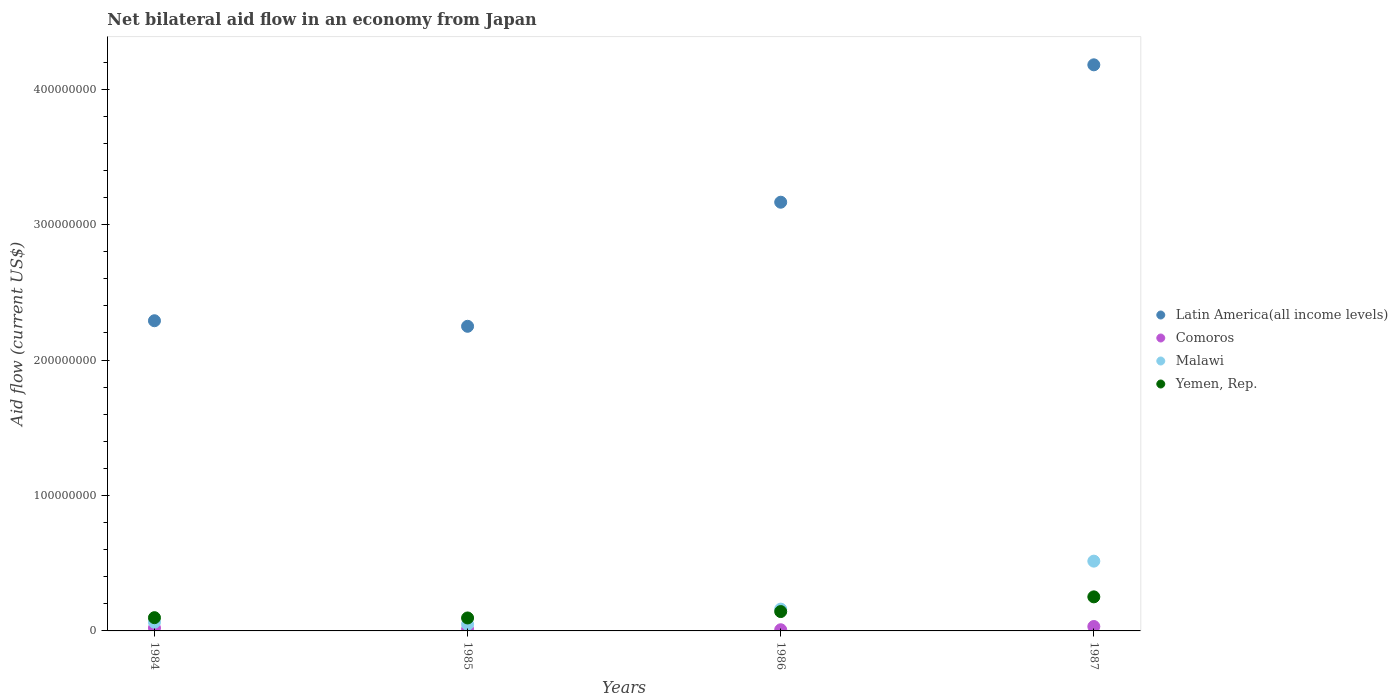Is the number of dotlines equal to the number of legend labels?
Make the answer very short. Yes. What is the net bilateral aid flow in Yemen, Rep. in 1984?
Give a very brief answer. 9.78e+06. Across all years, what is the maximum net bilateral aid flow in Yemen, Rep.?
Keep it short and to the point. 2.52e+07. Across all years, what is the minimum net bilateral aid flow in Comoros?
Offer a terse response. 8.60e+05. In which year was the net bilateral aid flow in Latin America(all income levels) maximum?
Your answer should be compact. 1987. What is the total net bilateral aid flow in Yemen, Rep. in the graph?
Provide a succinct answer. 5.88e+07. What is the difference between the net bilateral aid flow in Latin America(all income levels) in 1985 and that in 1987?
Keep it short and to the point. -1.93e+08. What is the difference between the net bilateral aid flow in Yemen, Rep. in 1985 and the net bilateral aid flow in Latin America(all income levels) in 1987?
Provide a short and direct response. -4.08e+08. What is the average net bilateral aid flow in Yemen, Rep. per year?
Keep it short and to the point. 1.47e+07. In the year 1984, what is the difference between the net bilateral aid flow in Latin America(all income levels) and net bilateral aid flow in Yemen, Rep.?
Provide a succinct answer. 2.19e+08. In how many years, is the net bilateral aid flow in Yemen, Rep. greater than 320000000 US$?
Your answer should be very brief. 0. What is the ratio of the net bilateral aid flow in Latin America(all income levels) in 1984 to that in 1986?
Provide a succinct answer. 0.72. Is the difference between the net bilateral aid flow in Latin America(all income levels) in 1985 and 1987 greater than the difference between the net bilateral aid flow in Yemen, Rep. in 1985 and 1987?
Your answer should be very brief. No. What is the difference between the highest and the second highest net bilateral aid flow in Yemen, Rep.?
Make the answer very short. 1.09e+07. What is the difference between the highest and the lowest net bilateral aid flow in Malawi?
Keep it short and to the point. 4.66e+07. Is it the case that in every year, the sum of the net bilateral aid flow in Yemen, Rep. and net bilateral aid flow in Comoros  is greater than the sum of net bilateral aid flow in Latin America(all income levels) and net bilateral aid flow in Malawi?
Offer a very short reply. No. Does the net bilateral aid flow in Malawi monotonically increase over the years?
Keep it short and to the point. No. Is the net bilateral aid flow in Yemen, Rep. strictly greater than the net bilateral aid flow in Latin America(all income levels) over the years?
Give a very brief answer. No. Is the net bilateral aid flow in Malawi strictly less than the net bilateral aid flow in Yemen, Rep. over the years?
Provide a succinct answer. No. How many dotlines are there?
Offer a very short reply. 4. Where does the legend appear in the graph?
Ensure brevity in your answer.  Center right. What is the title of the graph?
Provide a short and direct response. Net bilateral aid flow in an economy from Japan. Does "Palau" appear as one of the legend labels in the graph?
Your response must be concise. No. What is the Aid flow (current US$) of Latin America(all income levels) in 1984?
Keep it short and to the point. 2.29e+08. What is the Aid flow (current US$) of Comoros in 1984?
Your answer should be very brief. 2.18e+06. What is the Aid flow (current US$) of Malawi in 1984?
Offer a terse response. 6.40e+06. What is the Aid flow (current US$) in Yemen, Rep. in 1984?
Make the answer very short. 9.78e+06. What is the Aid flow (current US$) in Latin America(all income levels) in 1985?
Your answer should be compact. 2.25e+08. What is the Aid flow (current US$) of Comoros in 1985?
Make the answer very short. 1.21e+06. What is the Aid flow (current US$) of Malawi in 1985?
Offer a terse response. 4.88e+06. What is the Aid flow (current US$) in Yemen, Rep. in 1985?
Your answer should be very brief. 9.57e+06. What is the Aid flow (current US$) in Latin America(all income levels) in 1986?
Keep it short and to the point. 3.17e+08. What is the Aid flow (current US$) in Comoros in 1986?
Offer a very short reply. 8.60e+05. What is the Aid flow (current US$) of Malawi in 1986?
Make the answer very short. 1.61e+07. What is the Aid flow (current US$) in Yemen, Rep. in 1986?
Your answer should be compact. 1.43e+07. What is the Aid flow (current US$) of Latin America(all income levels) in 1987?
Your answer should be very brief. 4.18e+08. What is the Aid flow (current US$) in Comoros in 1987?
Offer a very short reply. 3.25e+06. What is the Aid flow (current US$) in Malawi in 1987?
Give a very brief answer. 5.15e+07. What is the Aid flow (current US$) of Yemen, Rep. in 1987?
Offer a very short reply. 2.52e+07. Across all years, what is the maximum Aid flow (current US$) of Latin America(all income levels)?
Keep it short and to the point. 4.18e+08. Across all years, what is the maximum Aid flow (current US$) in Comoros?
Provide a succinct answer. 3.25e+06. Across all years, what is the maximum Aid flow (current US$) of Malawi?
Provide a short and direct response. 5.15e+07. Across all years, what is the maximum Aid flow (current US$) in Yemen, Rep.?
Provide a succinct answer. 2.52e+07. Across all years, what is the minimum Aid flow (current US$) of Latin America(all income levels)?
Your answer should be compact. 2.25e+08. Across all years, what is the minimum Aid flow (current US$) of Comoros?
Your response must be concise. 8.60e+05. Across all years, what is the minimum Aid flow (current US$) in Malawi?
Provide a short and direct response. 4.88e+06. Across all years, what is the minimum Aid flow (current US$) in Yemen, Rep.?
Offer a terse response. 9.57e+06. What is the total Aid flow (current US$) of Latin America(all income levels) in the graph?
Offer a very short reply. 1.19e+09. What is the total Aid flow (current US$) in Comoros in the graph?
Offer a very short reply. 7.50e+06. What is the total Aid flow (current US$) of Malawi in the graph?
Provide a succinct answer. 7.89e+07. What is the total Aid flow (current US$) in Yemen, Rep. in the graph?
Provide a short and direct response. 5.88e+07. What is the difference between the Aid flow (current US$) in Latin America(all income levels) in 1984 and that in 1985?
Your answer should be very brief. 4.10e+06. What is the difference between the Aid flow (current US$) in Comoros in 1984 and that in 1985?
Offer a terse response. 9.70e+05. What is the difference between the Aid flow (current US$) of Malawi in 1984 and that in 1985?
Your response must be concise. 1.52e+06. What is the difference between the Aid flow (current US$) in Latin America(all income levels) in 1984 and that in 1986?
Offer a very short reply. -8.75e+07. What is the difference between the Aid flow (current US$) of Comoros in 1984 and that in 1986?
Your answer should be very brief. 1.32e+06. What is the difference between the Aid flow (current US$) of Malawi in 1984 and that in 1986?
Your answer should be very brief. -9.70e+06. What is the difference between the Aid flow (current US$) in Yemen, Rep. in 1984 and that in 1986?
Your response must be concise. -4.51e+06. What is the difference between the Aid flow (current US$) of Latin America(all income levels) in 1984 and that in 1987?
Ensure brevity in your answer.  -1.89e+08. What is the difference between the Aid flow (current US$) of Comoros in 1984 and that in 1987?
Keep it short and to the point. -1.07e+06. What is the difference between the Aid flow (current US$) of Malawi in 1984 and that in 1987?
Offer a terse response. -4.51e+07. What is the difference between the Aid flow (current US$) in Yemen, Rep. in 1984 and that in 1987?
Your response must be concise. -1.54e+07. What is the difference between the Aid flow (current US$) in Latin America(all income levels) in 1985 and that in 1986?
Make the answer very short. -9.16e+07. What is the difference between the Aid flow (current US$) in Comoros in 1985 and that in 1986?
Keep it short and to the point. 3.50e+05. What is the difference between the Aid flow (current US$) of Malawi in 1985 and that in 1986?
Offer a terse response. -1.12e+07. What is the difference between the Aid flow (current US$) in Yemen, Rep. in 1985 and that in 1986?
Keep it short and to the point. -4.72e+06. What is the difference between the Aid flow (current US$) in Latin America(all income levels) in 1985 and that in 1987?
Offer a terse response. -1.93e+08. What is the difference between the Aid flow (current US$) of Comoros in 1985 and that in 1987?
Offer a terse response. -2.04e+06. What is the difference between the Aid flow (current US$) of Malawi in 1985 and that in 1987?
Make the answer very short. -4.66e+07. What is the difference between the Aid flow (current US$) in Yemen, Rep. in 1985 and that in 1987?
Provide a short and direct response. -1.56e+07. What is the difference between the Aid flow (current US$) in Latin America(all income levels) in 1986 and that in 1987?
Keep it short and to the point. -1.01e+08. What is the difference between the Aid flow (current US$) of Comoros in 1986 and that in 1987?
Offer a terse response. -2.39e+06. What is the difference between the Aid flow (current US$) of Malawi in 1986 and that in 1987?
Your answer should be very brief. -3.54e+07. What is the difference between the Aid flow (current US$) in Yemen, Rep. in 1986 and that in 1987?
Your response must be concise. -1.09e+07. What is the difference between the Aid flow (current US$) of Latin America(all income levels) in 1984 and the Aid flow (current US$) of Comoros in 1985?
Your answer should be very brief. 2.28e+08. What is the difference between the Aid flow (current US$) in Latin America(all income levels) in 1984 and the Aid flow (current US$) in Malawi in 1985?
Ensure brevity in your answer.  2.24e+08. What is the difference between the Aid flow (current US$) of Latin America(all income levels) in 1984 and the Aid flow (current US$) of Yemen, Rep. in 1985?
Provide a succinct answer. 2.19e+08. What is the difference between the Aid flow (current US$) in Comoros in 1984 and the Aid flow (current US$) in Malawi in 1985?
Keep it short and to the point. -2.70e+06. What is the difference between the Aid flow (current US$) of Comoros in 1984 and the Aid flow (current US$) of Yemen, Rep. in 1985?
Ensure brevity in your answer.  -7.39e+06. What is the difference between the Aid flow (current US$) in Malawi in 1984 and the Aid flow (current US$) in Yemen, Rep. in 1985?
Give a very brief answer. -3.17e+06. What is the difference between the Aid flow (current US$) in Latin America(all income levels) in 1984 and the Aid flow (current US$) in Comoros in 1986?
Make the answer very short. 2.28e+08. What is the difference between the Aid flow (current US$) of Latin America(all income levels) in 1984 and the Aid flow (current US$) of Malawi in 1986?
Make the answer very short. 2.13e+08. What is the difference between the Aid flow (current US$) in Latin America(all income levels) in 1984 and the Aid flow (current US$) in Yemen, Rep. in 1986?
Give a very brief answer. 2.15e+08. What is the difference between the Aid flow (current US$) of Comoros in 1984 and the Aid flow (current US$) of Malawi in 1986?
Ensure brevity in your answer.  -1.39e+07. What is the difference between the Aid flow (current US$) in Comoros in 1984 and the Aid flow (current US$) in Yemen, Rep. in 1986?
Your answer should be compact. -1.21e+07. What is the difference between the Aid flow (current US$) of Malawi in 1984 and the Aid flow (current US$) of Yemen, Rep. in 1986?
Make the answer very short. -7.89e+06. What is the difference between the Aid flow (current US$) in Latin America(all income levels) in 1984 and the Aid flow (current US$) in Comoros in 1987?
Keep it short and to the point. 2.26e+08. What is the difference between the Aid flow (current US$) of Latin America(all income levels) in 1984 and the Aid flow (current US$) of Malawi in 1987?
Make the answer very short. 1.78e+08. What is the difference between the Aid flow (current US$) in Latin America(all income levels) in 1984 and the Aid flow (current US$) in Yemen, Rep. in 1987?
Provide a succinct answer. 2.04e+08. What is the difference between the Aid flow (current US$) in Comoros in 1984 and the Aid flow (current US$) in Malawi in 1987?
Provide a succinct answer. -4.93e+07. What is the difference between the Aid flow (current US$) in Comoros in 1984 and the Aid flow (current US$) in Yemen, Rep. in 1987?
Provide a succinct answer. -2.30e+07. What is the difference between the Aid flow (current US$) of Malawi in 1984 and the Aid flow (current US$) of Yemen, Rep. in 1987?
Your answer should be compact. -1.88e+07. What is the difference between the Aid flow (current US$) in Latin America(all income levels) in 1985 and the Aid flow (current US$) in Comoros in 1986?
Keep it short and to the point. 2.24e+08. What is the difference between the Aid flow (current US$) of Latin America(all income levels) in 1985 and the Aid flow (current US$) of Malawi in 1986?
Make the answer very short. 2.09e+08. What is the difference between the Aid flow (current US$) in Latin America(all income levels) in 1985 and the Aid flow (current US$) in Yemen, Rep. in 1986?
Keep it short and to the point. 2.11e+08. What is the difference between the Aid flow (current US$) of Comoros in 1985 and the Aid flow (current US$) of Malawi in 1986?
Your answer should be compact. -1.49e+07. What is the difference between the Aid flow (current US$) of Comoros in 1985 and the Aid flow (current US$) of Yemen, Rep. in 1986?
Your answer should be very brief. -1.31e+07. What is the difference between the Aid flow (current US$) of Malawi in 1985 and the Aid flow (current US$) of Yemen, Rep. in 1986?
Your answer should be very brief. -9.41e+06. What is the difference between the Aid flow (current US$) of Latin America(all income levels) in 1985 and the Aid flow (current US$) of Comoros in 1987?
Keep it short and to the point. 2.22e+08. What is the difference between the Aid flow (current US$) of Latin America(all income levels) in 1985 and the Aid flow (current US$) of Malawi in 1987?
Offer a terse response. 1.73e+08. What is the difference between the Aid flow (current US$) in Latin America(all income levels) in 1985 and the Aid flow (current US$) in Yemen, Rep. in 1987?
Give a very brief answer. 2.00e+08. What is the difference between the Aid flow (current US$) of Comoros in 1985 and the Aid flow (current US$) of Malawi in 1987?
Offer a very short reply. -5.03e+07. What is the difference between the Aid flow (current US$) in Comoros in 1985 and the Aid flow (current US$) in Yemen, Rep. in 1987?
Your response must be concise. -2.39e+07. What is the difference between the Aid flow (current US$) in Malawi in 1985 and the Aid flow (current US$) in Yemen, Rep. in 1987?
Offer a terse response. -2.03e+07. What is the difference between the Aid flow (current US$) of Latin America(all income levels) in 1986 and the Aid flow (current US$) of Comoros in 1987?
Keep it short and to the point. 3.13e+08. What is the difference between the Aid flow (current US$) in Latin America(all income levels) in 1986 and the Aid flow (current US$) in Malawi in 1987?
Your answer should be compact. 2.65e+08. What is the difference between the Aid flow (current US$) of Latin America(all income levels) in 1986 and the Aid flow (current US$) of Yemen, Rep. in 1987?
Your response must be concise. 2.91e+08. What is the difference between the Aid flow (current US$) of Comoros in 1986 and the Aid flow (current US$) of Malawi in 1987?
Give a very brief answer. -5.07e+07. What is the difference between the Aid flow (current US$) of Comoros in 1986 and the Aid flow (current US$) of Yemen, Rep. in 1987?
Your answer should be very brief. -2.43e+07. What is the difference between the Aid flow (current US$) in Malawi in 1986 and the Aid flow (current US$) in Yemen, Rep. in 1987?
Offer a terse response. -9.05e+06. What is the average Aid flow (current US$) of Latin America(all income levels) per year?
Give a very brief answer. 2.97e+08. What is the average Aid flow (current US$) of Comoros per year?
Give a very brief answer. 1.88e+06. What is the average Aid flow (current US$) in Malawi per year?
Give a very brief answer. 1.97e+07. What is the average Aid flow (current US$) in Yemen, Rep. per year?
Offer a terse response. 1.47e+07. In the year 1984, what is the difference between the Aid flow (current US$) in Latin America(all income levels) and Aid flow (current US$) in Comoros?
Provide a short and direct response. 2.27e+08. In the year 1984, what is the difference between the Aid flow (current US$) in Latin America(all income levels) and Aid flow (current US$) in Malawi?
Provide a succinct answer. 2.23e+08. In the year 1984, what is the difference between the Aid flow (current US$) in Latin America(all income levels) and Aid flow (current US$) in Yemen, Rep.?
Provide a short and direct response. 2.19e+08. In the year 1984, what is the difference between the Aid flow (current US$) in Comoros and Aid flow (current US$) in Malawi?
Give a very brief answer. -4.22e+06. In the year 1984, what is the difference between the Aid flow (current US$) in Comoros and Aid flow (current US$) in Yemen, Rep.?
Your answer should be compact. -7.60e+06. In the year 1984, what is the difference between the Aid flow (current US$) of Malawi and Aid flow (current US$) of Yemen, Rep.?
Ensure brevity in your answer.  -3.38e+06. In the year 1985, what is the difference between the Aid flow (current US$) in Latin America(all income levels) and Aid flow (current US$) in Comoros?
Your answer should be very brief. 2.24e+08. In the year 1985, what is the difference between the Aid flow (current US$) in Latin America(all income levels) and Aid flow (current US$) in Malawi?
Make the answer very short. 2.20e+08. In the year 1985, what is the difference between the Aid flow (current US$) of Latin America(all income levels) and Aid flow (current US$) of Yemen, Rep.?
Your answer should be compact. 2.15e+08. In the year 1985, what is the difference between the Aid flow (current US$) of Comoros and Aid flow (current US$) of Malawi?
Provide a succinct answer. -3.67e+06. In the year 1985, what is the difference between the Aid flow (current US$) in Comoros and Aid flow (current US$) in Yemen, Rep.?
Your answer should be compact. -8.36e+06. In the year 1985, what is the difference between the Aid flow (current US$) in Malawi and Aid flow (current US$) in Yemen, Rep.?
Make the answer very short. -4.69e+06. In the year 1986, what is the difference between the Aid flow (current US$) of Latin America(all income levels) and Aid flow (current US$) of Comoros?
Your response must be concise. 3.16e+08. In the year 1986, what is the difference between the Aid flow (current US$) in Latin America(all income levels) and Aid flow (current US$) in Malawi?
Your answer should be very brief. 3.00e+08. In the year 1986, what is the difference between the Aid flow (current US$) of Latin America(all income levels) and Aid flow (current US$) of Yemen, Rep.?
Offer a terse response. 3.02e+08. In the year 1986, what is the difference between the Aid flow (current US$) of Comoros and Aid flow (current US$) of Malawi?
Keep it short and to the point. -1.52e+07. In the year 1986, what is the difference between the Aid flow (current US$) in Comoros and Aid flow (current US$) in Yemen, Rep.?
Your response must be concise. -1.34e+07. In the year 1986, what is the difference between the Aid flow (current US$) in Malawi and Aid flow (current US$) in Yemen, Rep.?
Provide a short and direct response. 1.81e+06. In the year 1987, what is the difference between the Aid flow (current US$) in Latin America(all income levels) and Aid flow (current US$) in Comoros?
Give a very brief answer. 4.15e+08. In the year 1987, what is the difference between the Aid flow (current US$) in Latin America(all income levels) and Aid flow (current US$) in Malawi?
Your answer should be very brief. 3.66e+08. In the year 1987, what is the difference between the Aid flow (current US$) of Latin America(all income levels) and Aid flow (current US$) of Yemen, Rep.?
Make the answer very short. 3.93e+08. In the year 1987, what is the difference between the Aid flow (current US$) in Comoros and Aid flow (current US$) in Malawi?
Give a very brief answer. -4.83e+07. In the year 1987, what is the difference between the Aid flow (current US$) of Comoros and Aid flow (current US$) of Yemen, Rep.?
Your answer should be very brief. -2.19e+07. In the year 1987, what is the difference between the Aid flow (current US$) in Malawi and Aid flow (current US$) in Yemen, Rep.?
Offer a very short reply. 2.64e+07. What is the ratio of the Aid flow (current US$) in Latin America(all income levels) in 1984 to that in 1985?
Your response must be concise. 1.02. What is the ratio of the Aid flow (current US$) in Comoros in 1984 to that in 1985?
Provide a short and direct response. 1.8. What is the ratio of the Aid flow (current US$) of Malawi in 1984 to that in 1985?
Make the answer very short. 1.31. What is the ratio of the Aid flow (current US$) of Yemen, Rep. in 1984 to that in 1985?
Your answer should be very brief. 1.02. What is the ratio of the Aid flow (current US$) of Latin America(all income levels) in 1984 to that in 1986?
Offer a very short reply. 0.72. What is the ratio of the Aid flow (current US$) in Comoros in 1984 to that in 1986?
Provide a succinct answer. 2.53. What is the ratio of the Aid flow (current US$) in Malawi in 1984 to that in 1986?
Offer a very short reply. 0.4. What is the ratio of the Aid flow (current US$) in Yemen, Rep. in 1984 to that in 1986?
Provide a succinct answer. 0.68. What is the ratio of the Aid flow (current US$) in Latin America(all income levels) in 1984 to that in 1987?
Provide a short and direct response. 0.55. What is the ratio of the Aid flow (current US$) of Comoros in 1984 to that in 1987?
Keep it short and to the point. 0.67. What is the ratio of the Aid flow (current US$) in Malawi in 1984 to that in 1987?
Keep it short and to the point. 0.12. What is the ratio of the Aid flow (current US$) in Yemen, Rep. in 1984 to that in 1987?
Offer a terse response. 0.39. What is the ratio of the Aid flow (current US$) in Latin America(all income levels) in 1985 to that in 1986?
Make the answer very short. 0.71. What is the ratio of the Aid flow (current US$) in Comoros in 1985 to that in 1986?
Your response must be concise. 1.41. What is the ratio of the Aid flow (current US$) of Malawi in 1985 to that in 1986?
Your response must be concise. 0.3. What is the ratio of the Aid flow (current US$) of Yemen, Rep. in 1985 to that in 1986?
Your answer should be very brief. 0.67. What is the ratio of the Aid flow (current US$) of Latin America(all income levels) in 1985 to that in 1987?
Provide a short and direct response. 0.54. What is the ratio of the Aid flow (current US$) in Comoros in 1985 to that in 1987?
Make the answer very short. 0.37. What is the ratio of the Aid flow (current US$) of Malawi in 1985 to that in 1987?
Provide a short and direct response. 0.09. What is the ratio of the Aid flow (current US$) of Yemen, Rep. in 1985 to that in 1987?
Offer a terse response. 0.38. What is the ratio of the Aid flow (current US$) of Latin America(all income levels) in 1986 to that in 1987?
Make the answer very short. 0.76. What is the ratio of the Aid flow (current US$) in Comoros in 1986 to that in 1987?
Your response must be concise. 0.26. What is the ratio of the Aid flow (current US$) in Malawi in 1986 to that in 1987?
Make the answer very short. 0.31. What is the ratio of the Aid flow (current US$) in Yemen, Rep. in 1986 to that in 1987?
Offer a terse response. 0.57. What is the difference between the highest and the second highest Aid flow (current US$) of Latin America(all income levels)?
Keep it short and to the point. 1.01e+08. What is the difference between the highest and the second highest Aid flow (current US$) in Comoros?
Keep it short and to the point. 1.07e+06. What is the difference between the highest and the second highest Aid flow (current US$) in Malawi?
Your response must be concise. 3.54e+07. What is the difference between the highest and the second highest Aid flow (current US$) in Yemen, Rep.?
Make the answer very short. 1.09e+07. What is the difference between the highest and the lowest Aid flow (current US$) in Latin America(all income levels)?
Ensure brevity in your answer.  1.93e+08. What is the difference between the highest and the lowest Aid flow (current US$) in Comoros?
Provide a succinct answer. 2.39e+06. What is the difference between the highest and the lowest Aid flow (current US$) in Malawi?
Ensure brevity in your answer.  4.66e+07. What is the difference between the highest and the lowest Aid flow (current US$) in Yemen, Rep.?
Make the answer very short. 1.56e+07. 